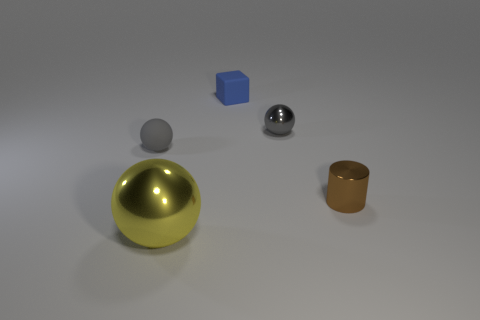Add 1 large gray rubber objects. How many objects exist? 6 Subtract all balls. How many objects are left? 2 Add 1 tiny yellow things. How many tiny yellow things exist? 1 Subtract 0 brown blocks. How many objects are left? 5 Subtract all brown metal cylinders. Subtract all big metallic spheres. How many objects are left? 3 Add 3 gray matte things. How many gray matte things are left? 4 